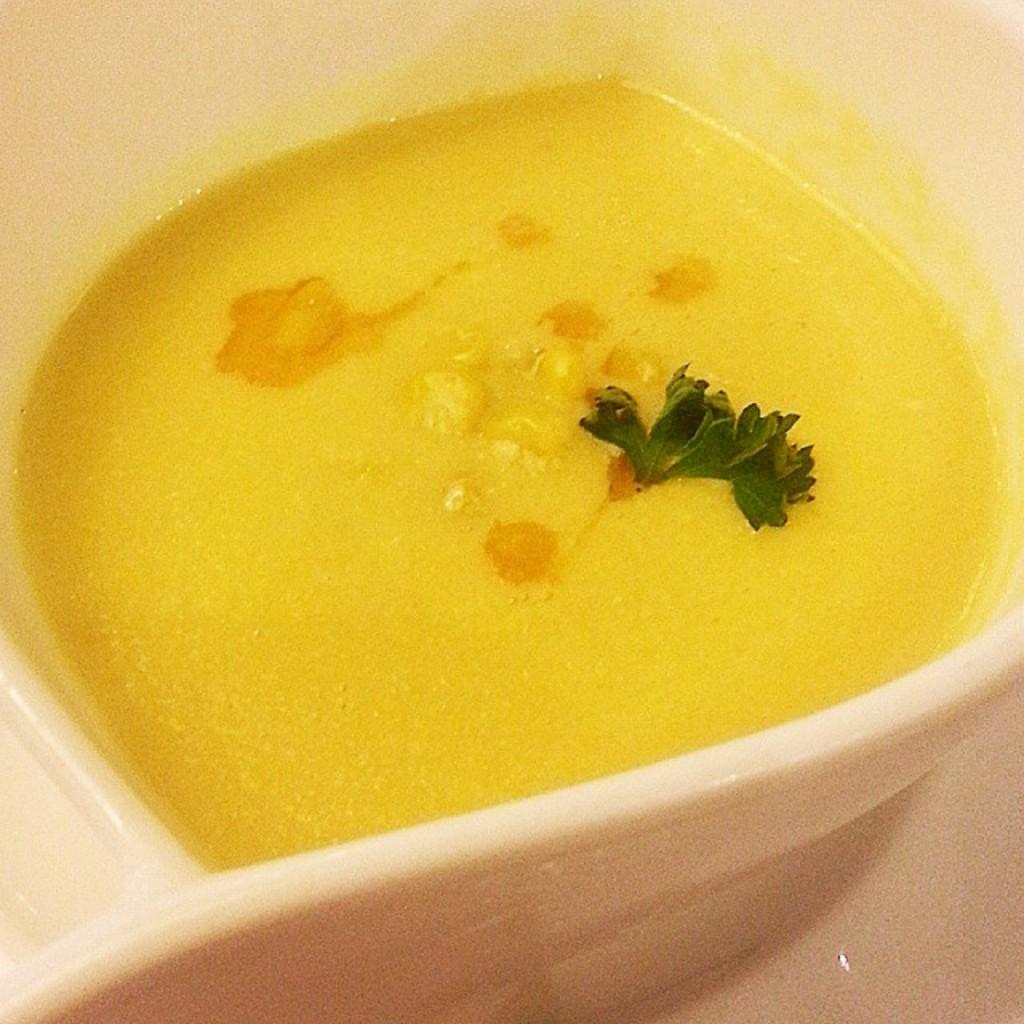What is the main subject of the image? There is a food item in the image. How is the food item presented in the image? The food item is on a plate. Where is the plate with the food item located? The plate is placed on a table. What page of the book is the food item located on in the image? There is no book present in the image, so the food item cannot be located on a page. 